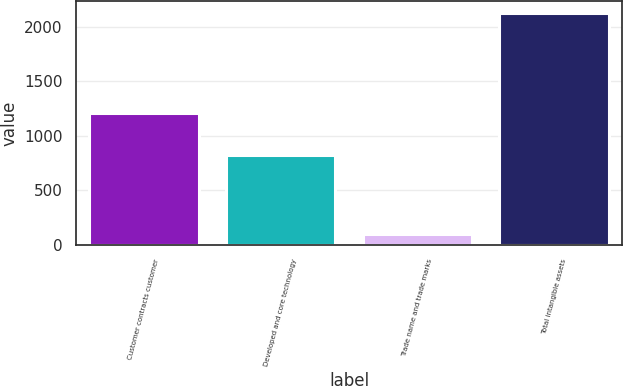Convert chart. <chart><loc_0><loc_0><loc_500><loc_500><bar_chart><fcel>Customer contracts customer<fcel>Developed and core technology<fcel>Trade name and trade marks<fcel>Total intangible assets<nl><fcel>1205<fcel>827<fcel>96<fcel>2128<nl></chart> 